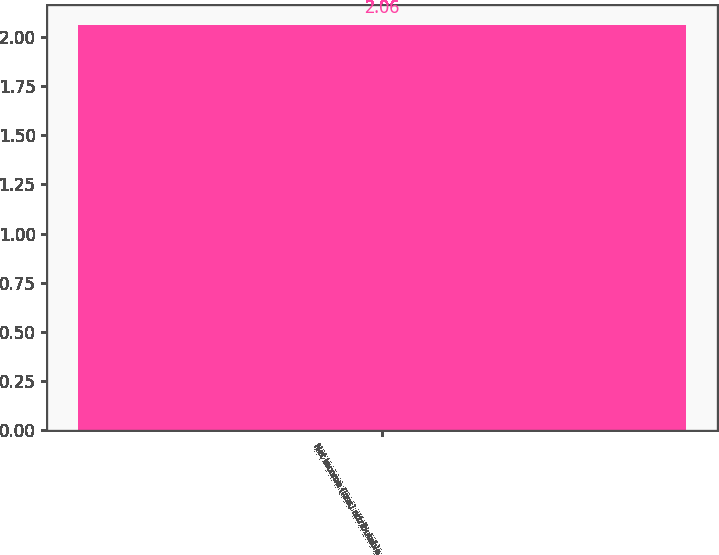<chart> <loc_0><loc_0><loc_500><loc_500><bar_chart><fcel>Net income (loss) attributable<nl><fcel>2.06<nl></chart> 